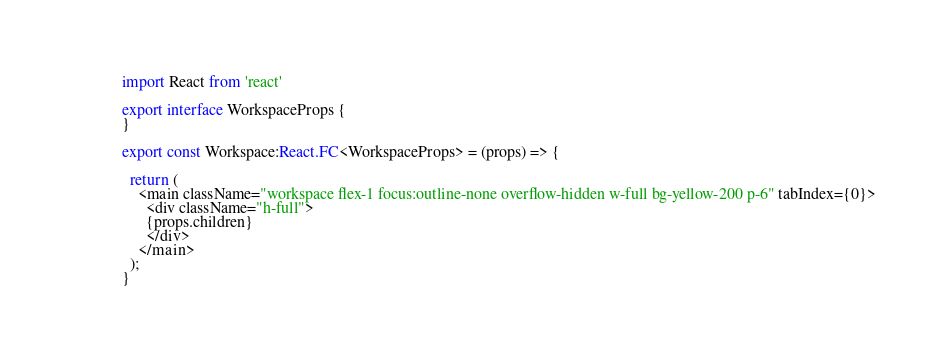Convert code to text. <code><loc_0><loc_0><loc_500><loc_500><_TypeScript_>import React from 'react'

export interface WorkspaceProps {
}

export const Workspace:React.FC<WorkspaceProps> = (props) => {

  return (
    <main className="workspace flex-1 focus:outline-none overflow-hidden w-full bg-yellow-200 p-6" tabIndex={0}>
      <div className="h-full">
      {props.children}
      </div>
    </main>
  );
}
</code> 